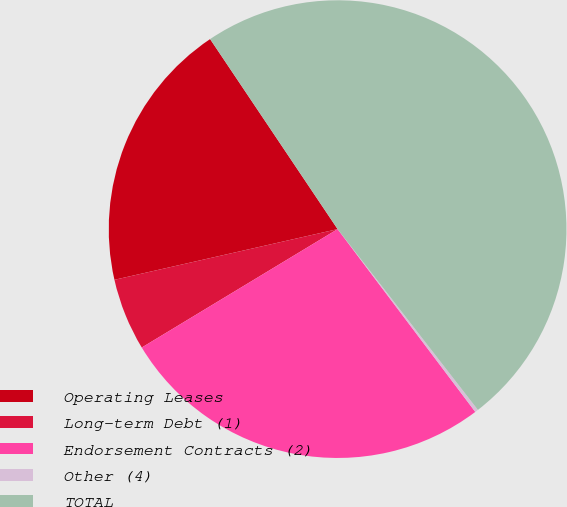<chart> <loc_0><loc_0><loc_500><loc_500><pie_chart><fcel>Operating Leases<fcel>Long-term Debt (1)<fcel>Endorsement Contracts (2)<fcel>Other (4)<fcel>TOTAL<nl><fcel>19.15%<fcel>5.1%<fcel>26.62%<fcel>0.23%<fcel>48.9%<nl></chart> 